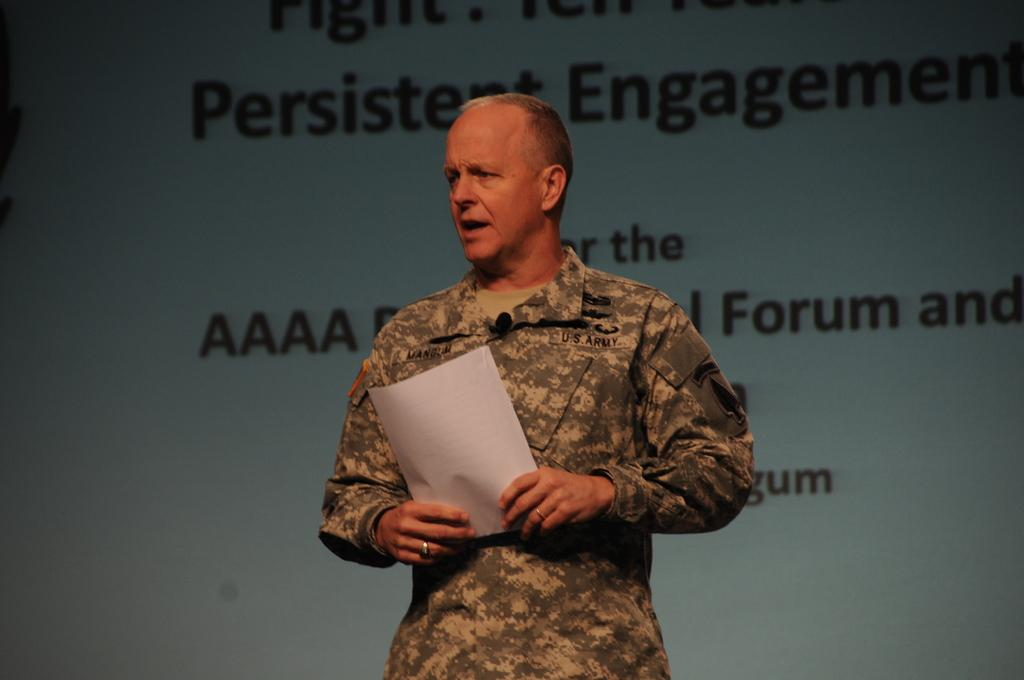What is the person in the image doing? The person is standing and speaking, holding a paper and wearing a mic. What might the person be using the paper for? The person might be using the paper as a reference or to read from while speaking. What can be seen in the background of the image? There is a wall in the background of the image, with writing on it. What is the person's attire in the image? The person is wearing a mic, which suggests they are in a professional or public speaking setting. What type of rifle can be seen leaning against the wall in the image? There is no rifle present in the image; only a person, a paper, a mic, and a wall with writing are visible. 